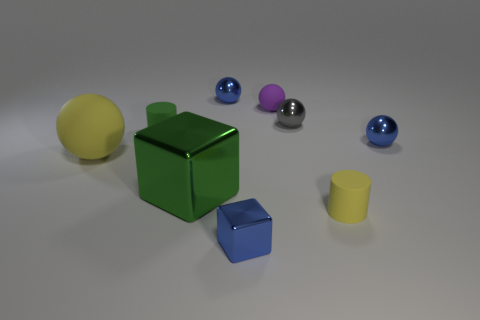There is a tiny sphere to the left of the rubber sphere right of the yellow rubber sphere; what is its color?
Your answer should be compact. Blue. Is the size of the gray metal sphere the same as the purple ball?
Keep it short and to the point. Yes. What color is the sphere that is left of the blue block and right of the large yellow thing?
Offer a terse response. Blue. The yellow ball is what size?
Give a very brief answer. Large. Do the ball that is on the left side of the big green metal cube and the tiny rubber sphere have the same color?
Offer a very short reply. No. Is the number of small blue things left of the large metallic thing greater than the number of tiny rubber objects that are in front of the big yellow matte object?
Offer a very short reply. No. Is the number of big brown metallic things greater than the number of blue things?
Offer a very short reply. No. How big is the sphere that is both on the left side of the tiny purple ball and behind the green cylinder?
Provide a short and direct response. Small. The small purple thing has what shape?
Ensure brevity in your answer.  Sphere. Are there any other things that are the same size as the purple rubber ball?
Make the answer very short. Yes. 